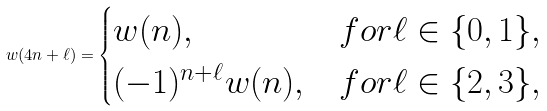<formula> <loc_0><loc_0><loc_500><loc_500>w ( 4 n + \ell ) = \begin{cases} w ( n ) , & f o r \ell \in \{ 0 , 1 \} , \\ ( - 1 ) ^ { n + \ell } w ( n ) , & f o r \ell \in \{ 2 , 3 \} , \ \end{cases}</formula> 